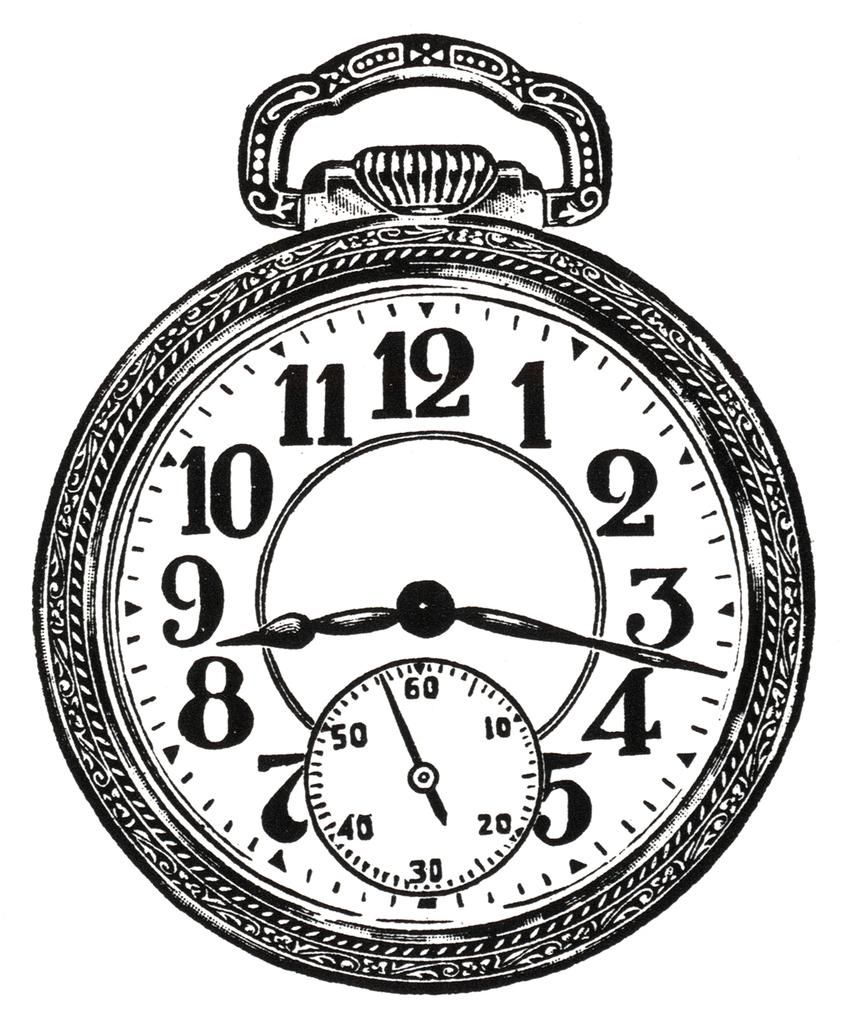<image>
Create a compact narrative representing the image presented. Black and white clock showing the time at 9:17 and a compass  of55. 